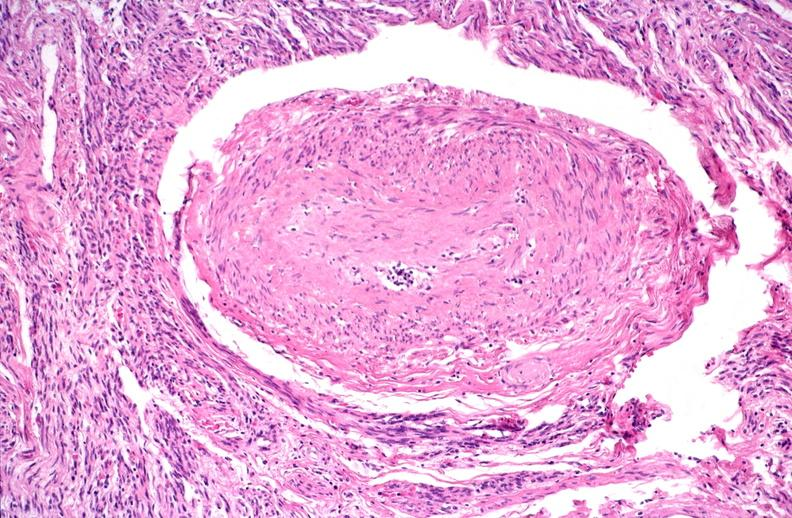where is this?
Answer the question using a single word or phrase. Urinary 